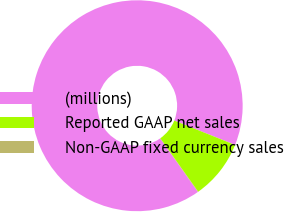Convert chart to OTSL. <chart><loc_0><loc_0><loc_500><loc_500><pie_chart><fcel>(millions)<fcel>Reported GAAP net sales<fcel>Non-GAAP fixed currency sales<nl><fcel>90.83%<fcel>9.12%<fcel>0.05%<nl></chart> 